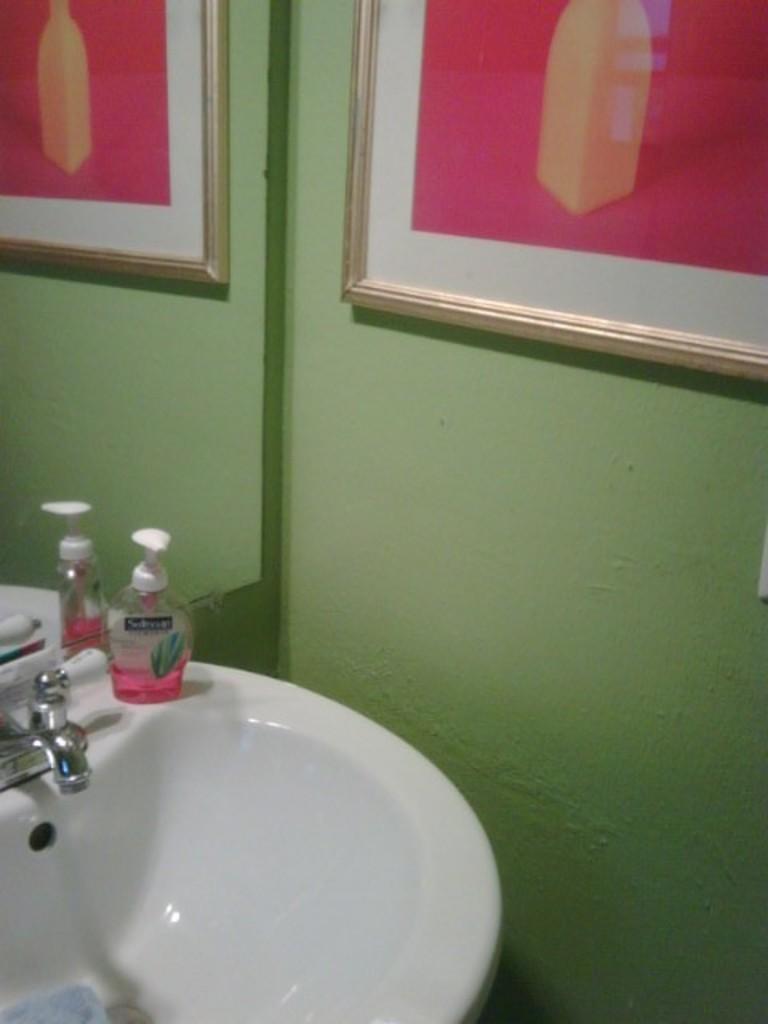In one or two sentences, can you explain what this image depicts? In this image we can see a sink, tap, bottle and a photo frame on the wall, there is a mirror, in the mirror we can see a reflection of a photo frame. 